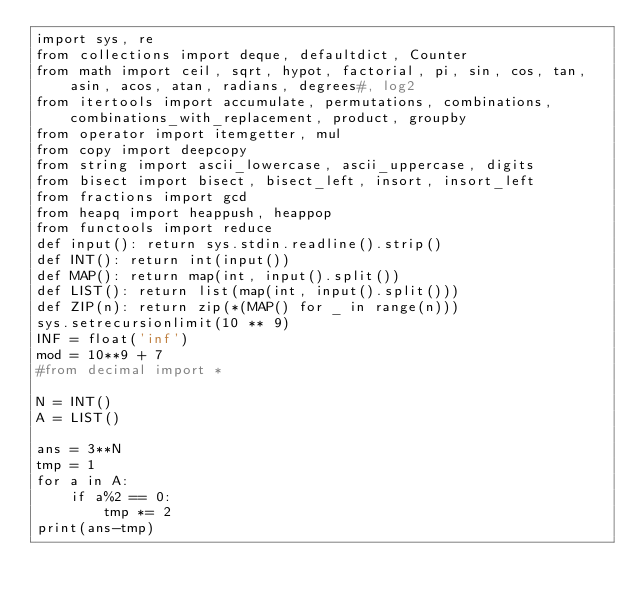<code> <loc_0><loc_0><loc_500><loc_500><_Python_>import sys, re
from collections import deque, defaultdict, Counter
from math import ceil, sqrt, hypot, factorial, pi, sin, cos, tan, asin, acos, atan, radians, degrees#, log2
from itertools import accumulate, permutations, combinations, combinations_with_replacement, product, groupby
from operator import itemgetter, mul
from copy import deepcopy
from string import ascii_lowercase, ascii_uppercase, digits
from bisect import bisect, bisect_left, insort, insort_left
from fractions import gcd
from heapq import heappush, heappop
from functools import reduce
def input(): return sys.stdin.readline().strip()
def INT(): return int(input())
def MAP(): return map(int, input().split())
def LIST(): return list(map(int, input().split()))
def ZIP(n): return zip(*(MAP() for _ in range(n)))
sys.setrecursionlimit(10 ** 9)
INF = float('inf')
mod = 10**9 + 7
#from decimal import *

N = INT()
A = LIST()

ans = 3**N
tmp = 1
for a in A:
	if a%2 == 0:
		tmp *= 2
print(ans-tmp)</code> 